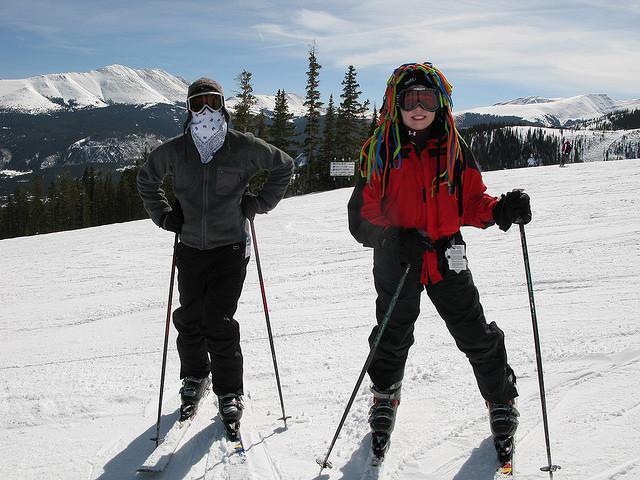How many people are posed?
Give a very brief answer. 2. How many people are visible?
Give a very brief answer. 2. 